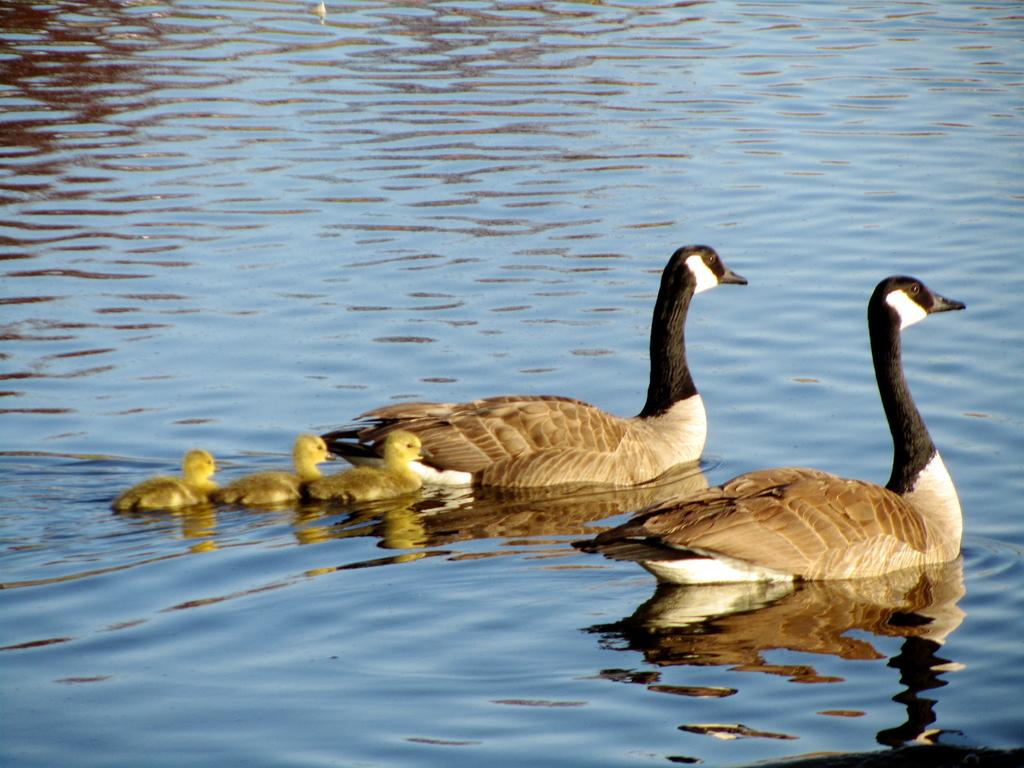How many ducks and ducklings are in the image? There are two ducks and three ducklings in the image. Where are the ducks and ducklings located? The ducks and ducklings are in the water. What might the ducks and ducklings be doing in the water? They might be swimming or floating in the water. What type of crate can be seen in the image? There is no crate present in the image. How many crows are visible in the image? There are no crows present in the image. 